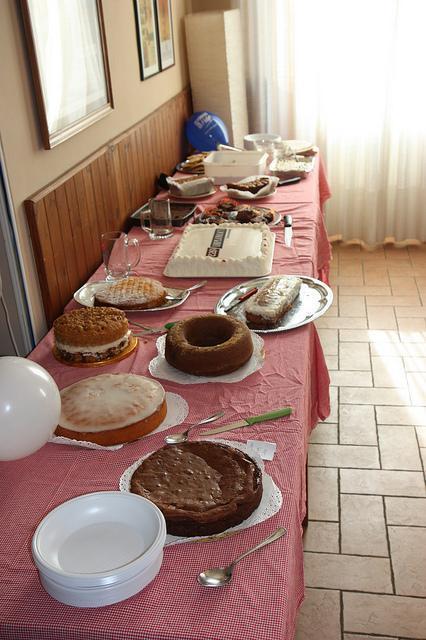How many cakes are there?
Give a very brief answer. 7. 